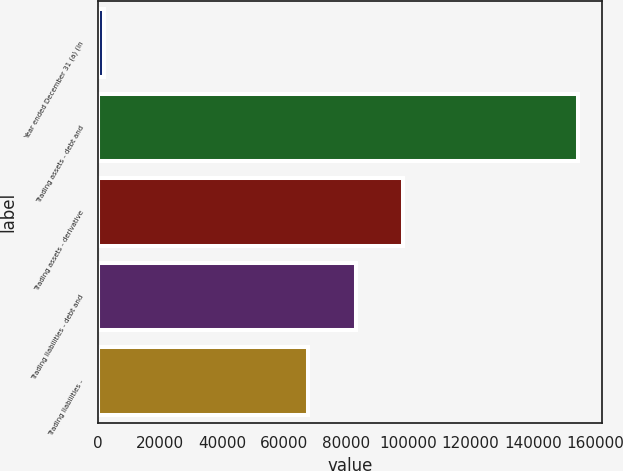Convert chart. <chart><loc_0><loc_0><loc_500><loc_500><bar_chart><fcel>Year ended December 31 (a) (in<fcel>Trading assets - debt and<fcel>Trading assets - derivative<fcel>Trading liabilities - debt and<fcel>Trading liabilities -<nl><fcel>2003<fcel>154597<fcel>98301.8<fcel>83042.4<fcel>67783<nl></chart> 